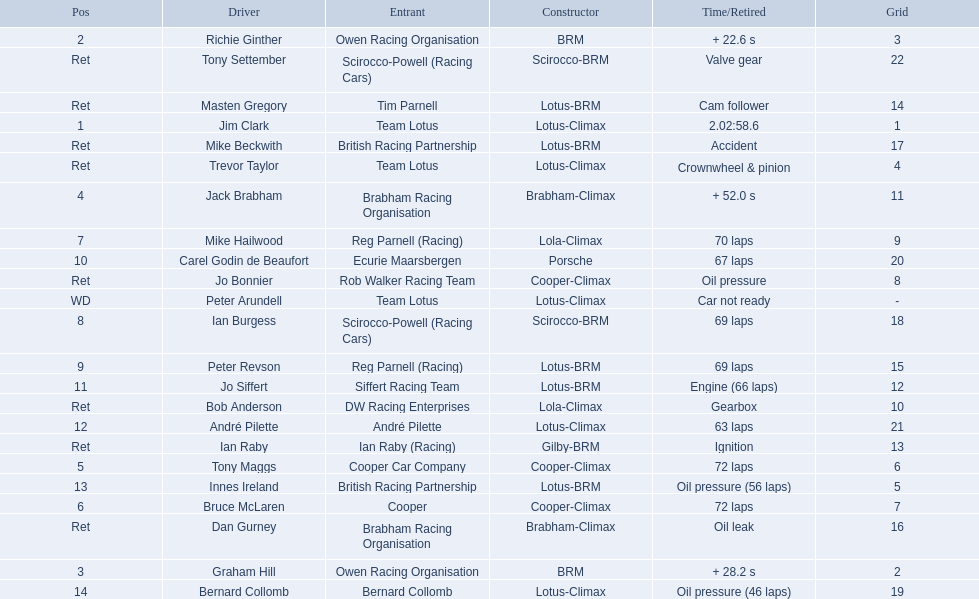Who were the drivers at the 1963 international gold cup? Jim Clark, Richie Ginther, Graham Hill, Jack Brabham, Tony Maggs, Bruce McLaren, Mike Hailwood, Ian Burgess, Peter Revson, Carel Godin de Beaufort, Jo Siffert, André Pilette, Innes Ireland, Bernard Collomb, Ian Raby, Dan Gurney, Mike Beckwith, Masten Gregory, Trevor Taylor, Jo Bonnier, Tony Settember, Bob Anderson, Peter Arundell. What was tony maggs position? 5. What was jo siffert? 11. Who came in earlier? Tony Maggs. 